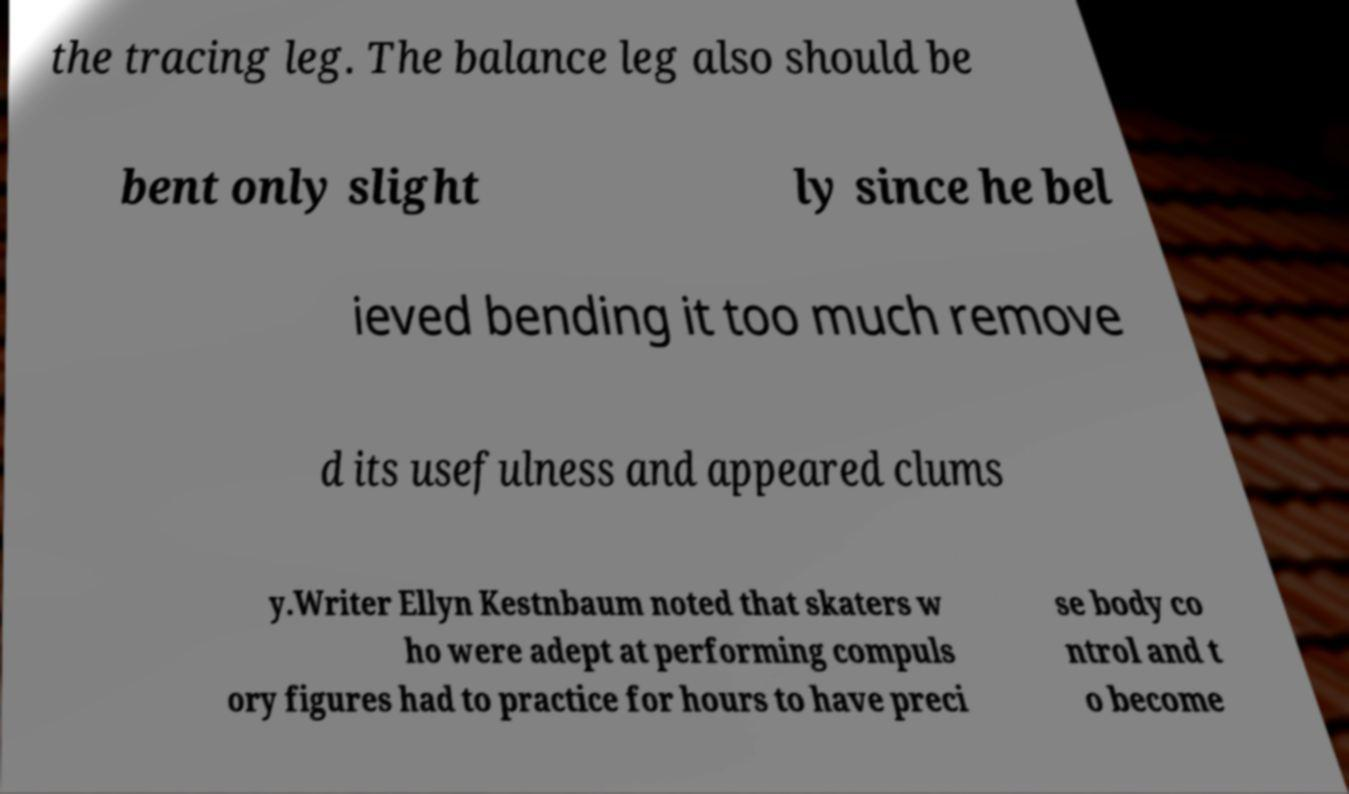Could you extract and type out the text from this image? the tracing leg. The balance leg also should be bent only slight ly since he bel ieved bending it too much remove d its usefulness and appeared clums y.Writer Ellyn Kestnbaum noted that skaters w ho were adept at performing compuls ory figures had to practice for hours to have preci se body co ntrol and t o become 